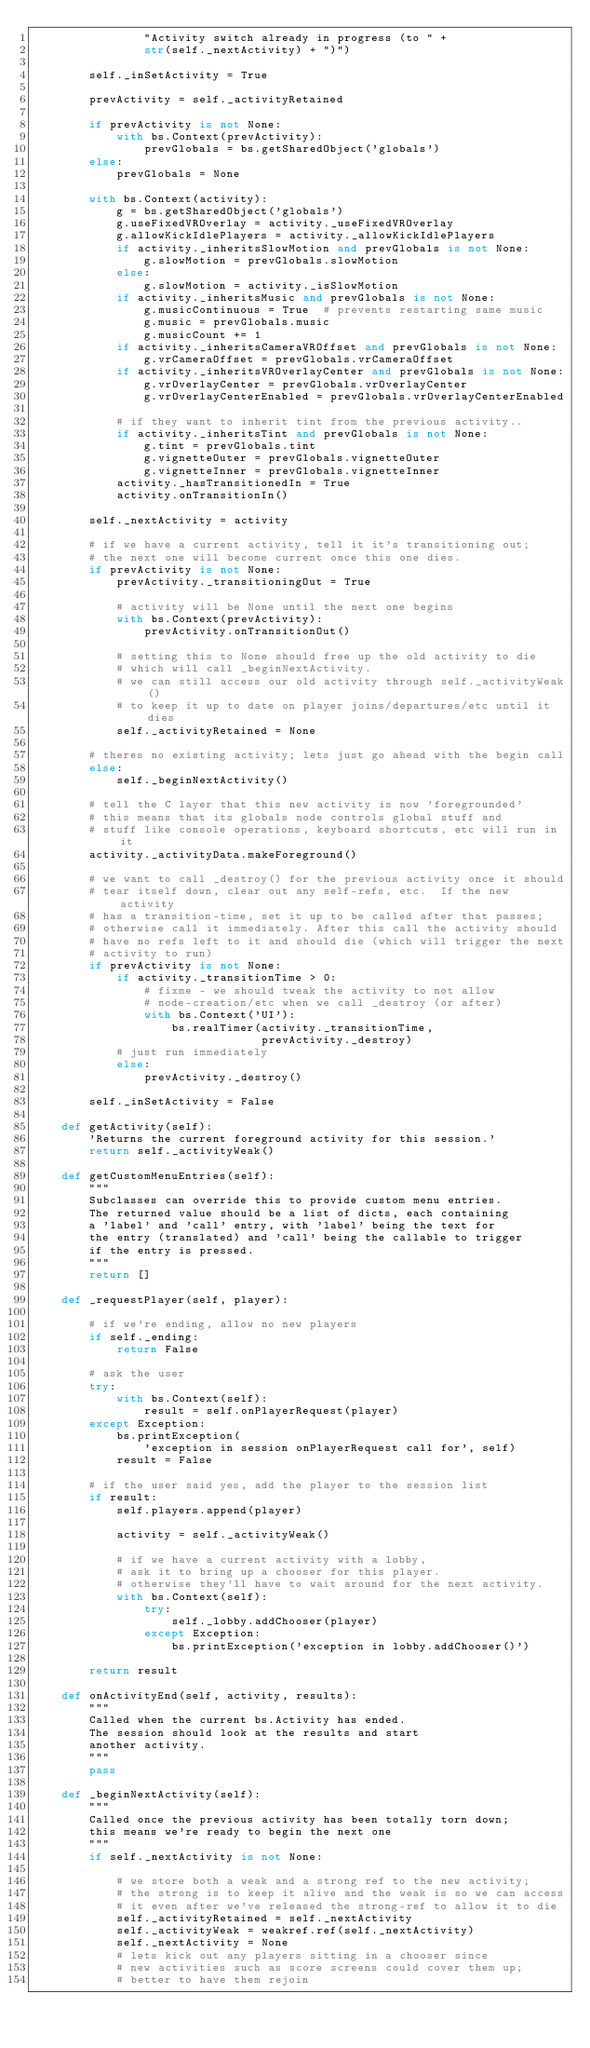Convert code to text. <code><loc_0><loc_0><loc_500><loc_500><_Python_>                "Activity switch already in progress (to " +
                str(self._nextActivity) + ")")

        self._inSetActivity = True

        prevActivity = self._activityRetained

        if prevActivity is not None:
            with bs.Context(prevActivity):
                prevGlobals = bs.getSharedObject('globals')
        else:
            prevGlobals = None

        with bs.Context(activity):
            g = bs.getSharedObject('globals')
            g.useFixedVROverlay = activity._useFixedVROverlay
            g.allowKickIdlePlayers = activity._allowKickIdlePlayers
            if activity._inheritsSlowMotion and prevGlobals is not None:
                g.slowMotion = prevGlobals.slowMotion
            else:
                g.slowMotion = activity._isSlowMotion
            if activity._inheritsMusic and prevGlobals is not None:
                g.musicContinuous = True  # prevents restarting same music
                g.music = prevGlobals.music
                g.musicCount += 1
            if activity._inheritsCameraVROffset and prevGlobals is not None:
                g.vrCameraOffset = prevGlobals.vrCameraOffset
            if activity._inheritsVROverlayCenter and prevGlobals is not None:
                g.vrOverlayCenter = prevGlobals.vrOverlayCenter
                g.vrOverlayCenterEnabled = prevGlobals.vrOverlayCenterEnabled

            # if they want to inherit tint from the previous activity..
            if activity._inheritsTint and prevGlobals is not None:
                g.tint = prevGlobals.tint
                g.vignetteOuter = prevGlobals.vignetteOuter
                g.vignetteInner = prevGlobals.vignetteInner
            activity._hasTransitionedIn = True
            activity.onTransitionIn()

        self._nextActivity = activity

        # if we have a current activity, tell it it's transitioning out;
        # the next one will become current once this one dies.
        if prevActivity is not None:
            prevActivity._transitioningOut = True

            # activity will be None until the next one begins
            with bs.Context(prevActivity):
                prevActivity.onTransitionOut()

            # setting this to None should free up the old activity to die
            # which will call _beginNextActivity.
            # we can still access our old activity through self._activityWeak()
            # to keep it up to date on player joins/departures/etc until it dies
            self._activityRetained = None

        # theres no existing activity; lets just go ahead with the begin call
        else:
            self._beginNextActivity()

        # tell the C layer that this new activity is now 'foregrounded'
        # this means that its globals node controls global stuff and
        # stuff like console operations, keyboard shortcuts, etc will run in it
        activity._activityData.makeForeground()

        # we want to call _destroy() for the previous activity once it should
        # tear itself down, clear out any self-refs, etc.  If the new activity
        # has a transition-time, set it up to be called after that passes;
        # otherwise call it immediately. After this call the activity should
        # have no refs left to it and should die (which will trigger the next
        # activity to run)
        if prevActivity is not None:
            if activity._transitionTime > 0:
                # fixme - we should tweak the activity to not allow
                # node-creation/etc when we call _destroy (or after)
                with bs.Context('UI'):
                    bs.realTimer(activity._transitionTime,
                                 prevActivity._destroy)
            # just run immediately
            else:
                prevActivity._destroy()

        self._inSetActivity = False

    def getActivity(self):
        'Returns the current foreground activity for this session.'
        return self._activityWeak()

    def getCustomMenuEntries(self):
        """
        Subclasses can override this to provide custom menu entries.
        The returned value should be a list of dicts, each containing
        a 'label' and 'call' entry, with 'label' being the text for
        the entry (translated) and 'call' being the callable to trigger
        if the entry is pressed.
        """
        return []

    def _requestPlayer(self, player):

        # if we're ending, allow no new players
        if self._ending:
            return False

        # ask the user
        try:
            with bs.Context(self):
                result = self.onPlayerRequest(player)
        except Exception:
            bs.printException(
                'exception in session onPlayerRequest call for', self)
            result = False

        # if the user said yes, add the player to the session list
        if result:
            self.players.append(player)

            activity = self._activityWeak()

            # if we have a current activity with a lobby,
            # ask it to bring up a chooser for this player.
            # otherwise they'll have to wait around for the next activity.
            with bs.Context(self):
                try:
                    self._lobby.addChooser(player)
                except Exception:
                    bs.printException('exception in lobby.addChooser()')

        return result

    def onActivityEnd(self, activity, results):
        """
        Called when the current bs.Activity has ended.
        The session should look at the results and start
        another activity.
        """
        pass

    def _beginNextActivity(self):
        """
        Called once the previous activity has been totally torn down;
        this means we're ready to begin the next one
        """
        if self._nextActivity is not None:

            # we store both a weak and a strong ref to the new activity;
            # the strong is to keep it alive and the weak is so we can access
            # it even after we've released the strong-ref to allow it to die
            self._activityRetained = self._nextActivity
            self._activityWeak = weakref.ref(self._nextActivity)
            self._nextActivity = None
            # lets kick out any players sitting in a chooser since
            # new activities such as score screens could cover them up;
            # better to have them rejoin</code> 